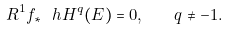Convert formula to latex. <formula><loc_0><loc_0><loc_500><loc_500>R ^ { 1 } f _ { \ast } \ h H ^ { q } ( E ) = 0 , \quad q \neq - 1 .</formula> 